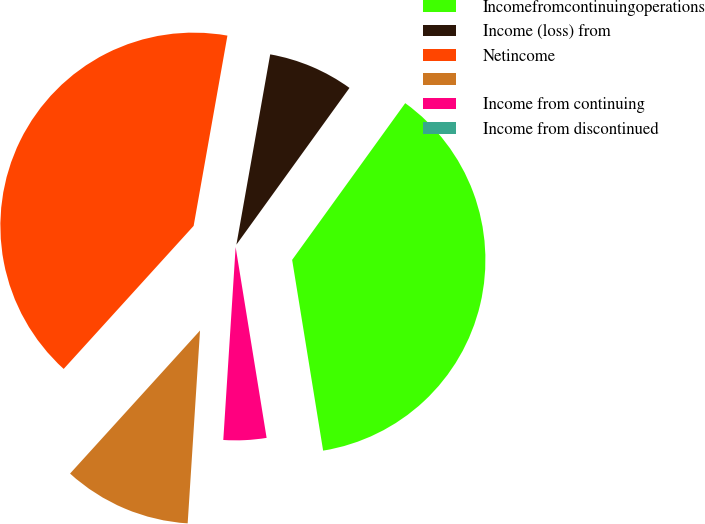Convert chart to OTSL. <chart><loc_0><loc_0><loc_500><loc_500><pie_chart><fcel>Incomefromcontinuingoperations<fcel>Income (loss) from<fcel>Netincome<fcel>Unnamed: 3<fcel>Income from continuing<fcel>Income from discontinued<nl><fcel>37.49%<fcel>7.15%<fcel>41.06%<fcel>10.72%<fcel>3.58%<fcel>0.0%<nl></chart> 